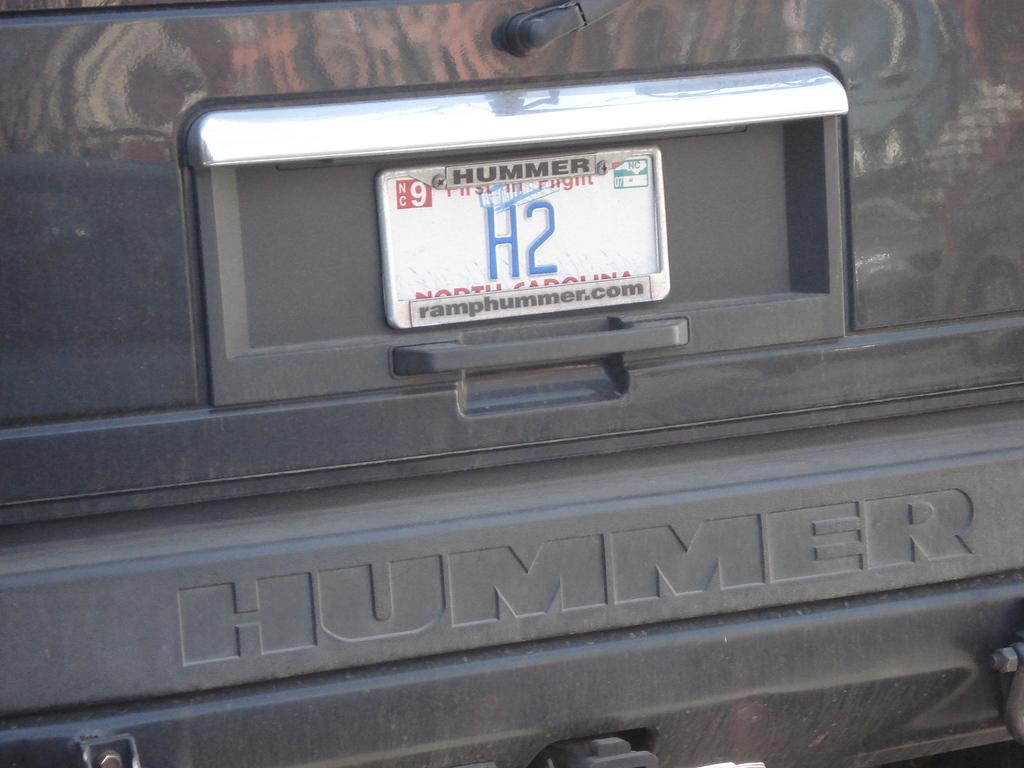<image>
Offer a succinct explanation of the picture presented. The license plate number is H2 and is protected by a frame from ramphummer.com.. 